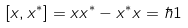<formula> <loc_0><loc_0><loc_500><loc_500>\left [ x , x ^ { * } \right ] = x x ^ { * } - x ^ { * } x = \hbar { 1 }</formula> 